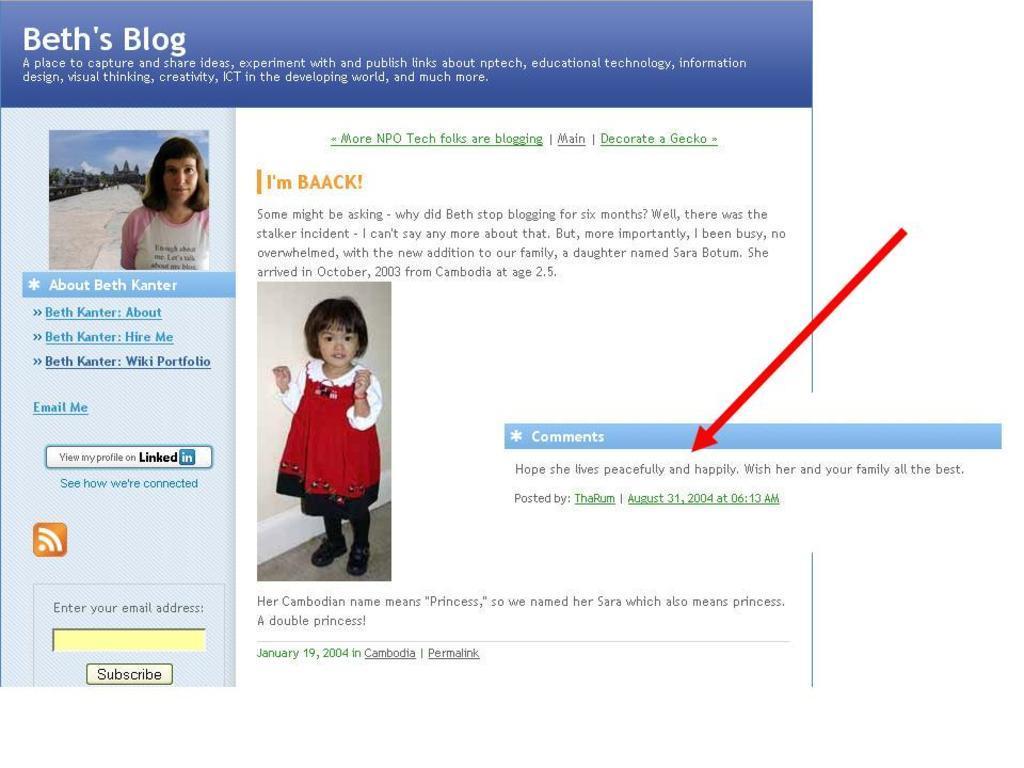Please provide a concise description of this image. This image consists of a screenshot of a screen. In which we can see the pictures of two persons along with the text.. 